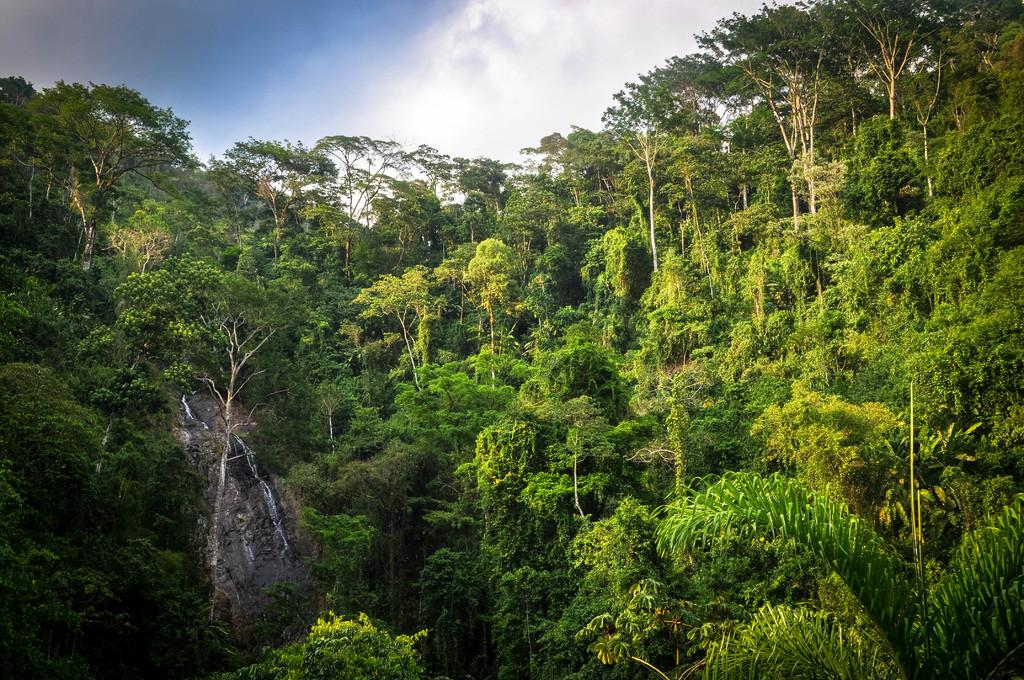What type of vegetation can be seen in the image? There are trees in the image. What natural element is visible in the image? Water is visible in the image. What part of the sky is visible in the image? The sky is visible in the image. What atmospheric feature can be seen in the sky? Clouds are present in the image. What emotion is the squirrel displaying in the image? There is no squirrel present in the image, so it is not possible to determine any emotions being displayed. 